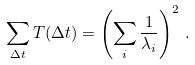Convert formula to latex. <formula><loc_0><loc_0><loc_500><loc_500>\sum _ { \Delta t } T ( \Delta t ) = \left ( \sum _ { i } \frac { 1 } { \lambda _ { i } } \right ) ^ { 2 } \, .</formula> 